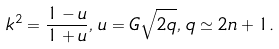Convert formula to latex. <formula><loc_0><loc_0><loc_500><loc_500>k ^ { 2 } = \frac { 1 - u } { 1 + u } , \, u = G \sqrt { 2 q } , \, q \simeq 2 n + 1 .</formula> 